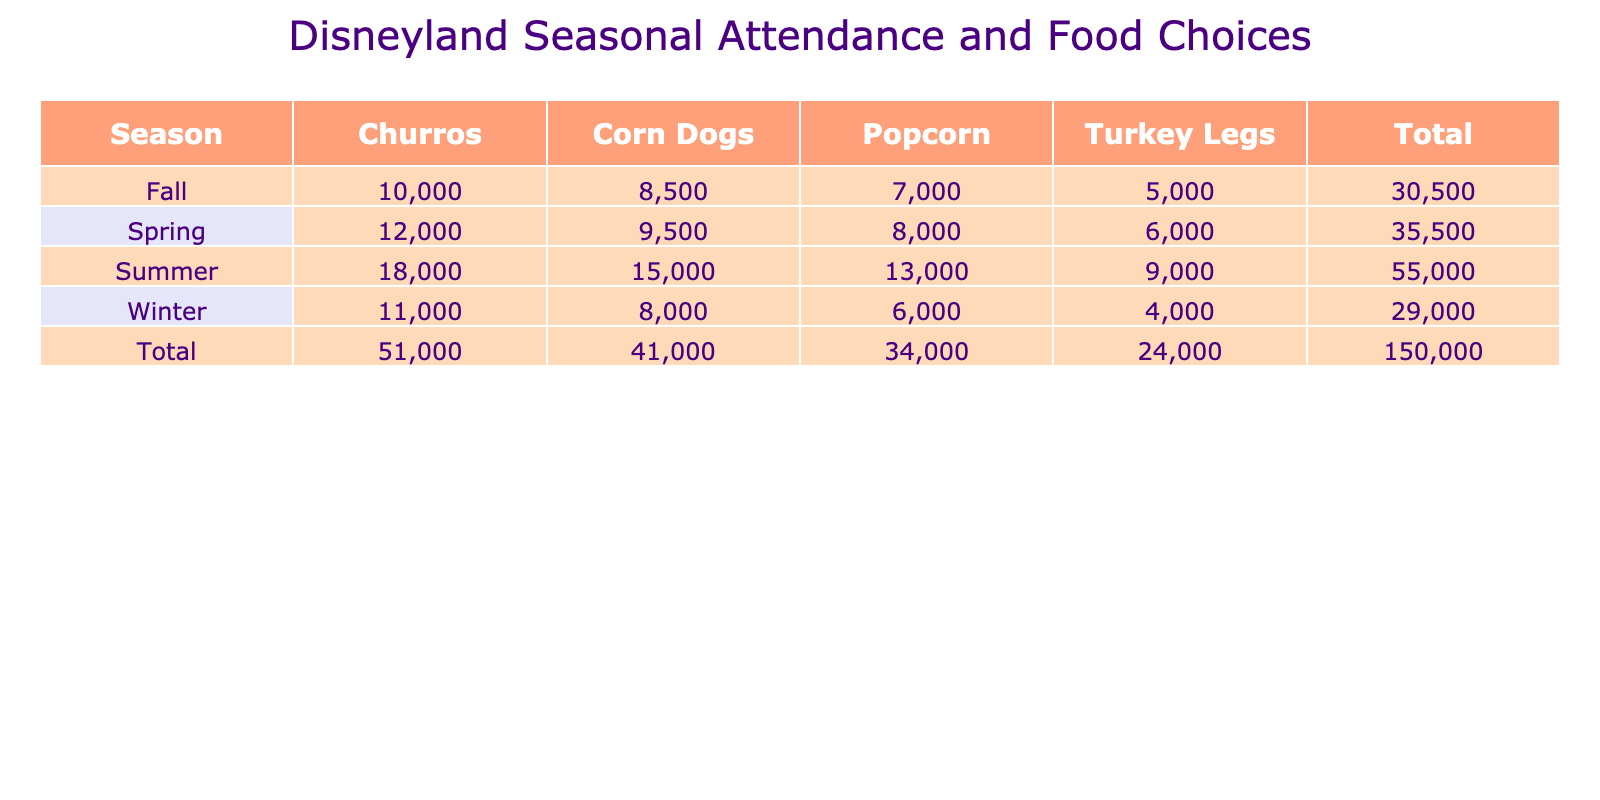What is the total attendance for Summer? To find the total attendance for Summer, we look at the Summer row in the table and sum the attendance numbers for all food choices: Churros (18000), Corn Dogs (15000), Popcorn (13000), and Turkey Legs (9000). Adding these gives us 18000 + 15000 + 13000 + 9000 = 60000.
Answer: 60000 Which food choice had the highest attendance in the Fall season? Looking at the Fall row, we compare the attendance numbers: Churros (10000), Corn Dogs (8500), Popcorn (7000), and Turkey Legs (5000). The highest number is for Churros, which has an attendance of 10000.
Answer: Churros Is the attendance for Corn Dogs in Winter greater than that in Spring? In the Winter, attendance for Corn Dogs is 8000, and in Spring, it is 9500. Since 8000 is less than 9500, this statement is false.
Answer: No What is the average attendance for Turkey Legs across all seasons? We find the attendance for Turkey Legs in each season: Spring (6000), Summer (9000), Fall (5000), and Winter (4000). To calculate the average, we sum these values: 6000 + 9000 + 5000 + 4000 = 24000. Then we divide by the number of seasons, which is 4: 24000 / 4 = 6000.
Answer: 6000 How many more people attended Churros in Summer compared to Winter? In Summer, the attendance for Churros is 18000, and in Winter, it is 11000. To find the difference, we calculate: 18000 - 11000 = 7000. This means 7000 more people attended Churros in Summer compared to Winter.
Answer: 7000 